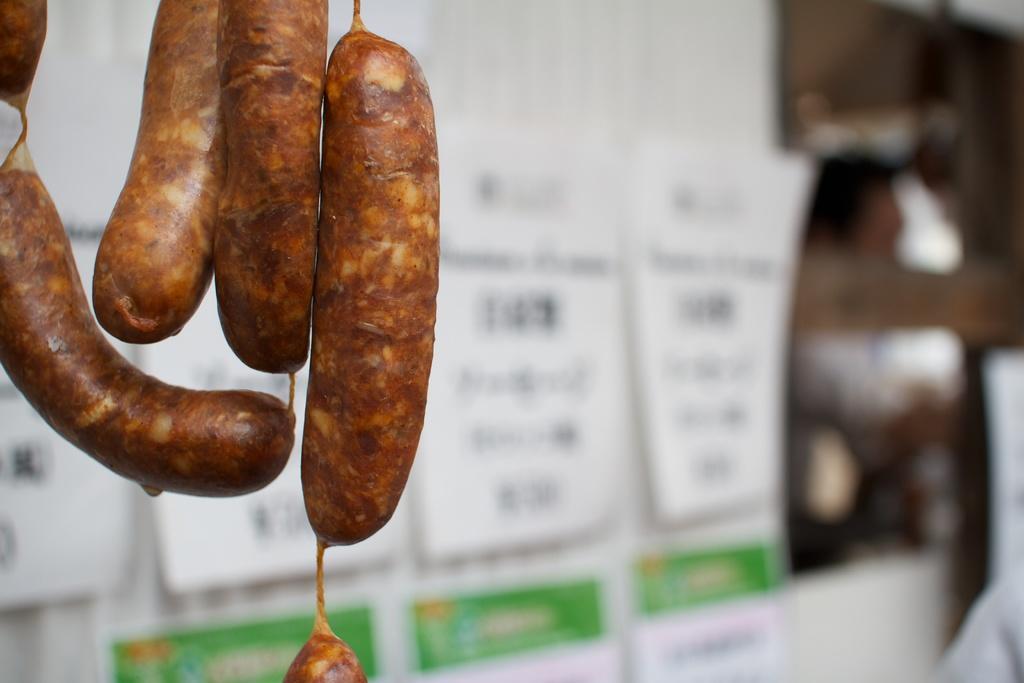In one or two sentences, can you explain what this image depicts? On the left side, we see the sausages. Behind that, we see the posters or charts in white and green color with some text written on it. Behind that, we see a white wall. On the right side, it is in brown and white color. This picture is blurred in the background. 